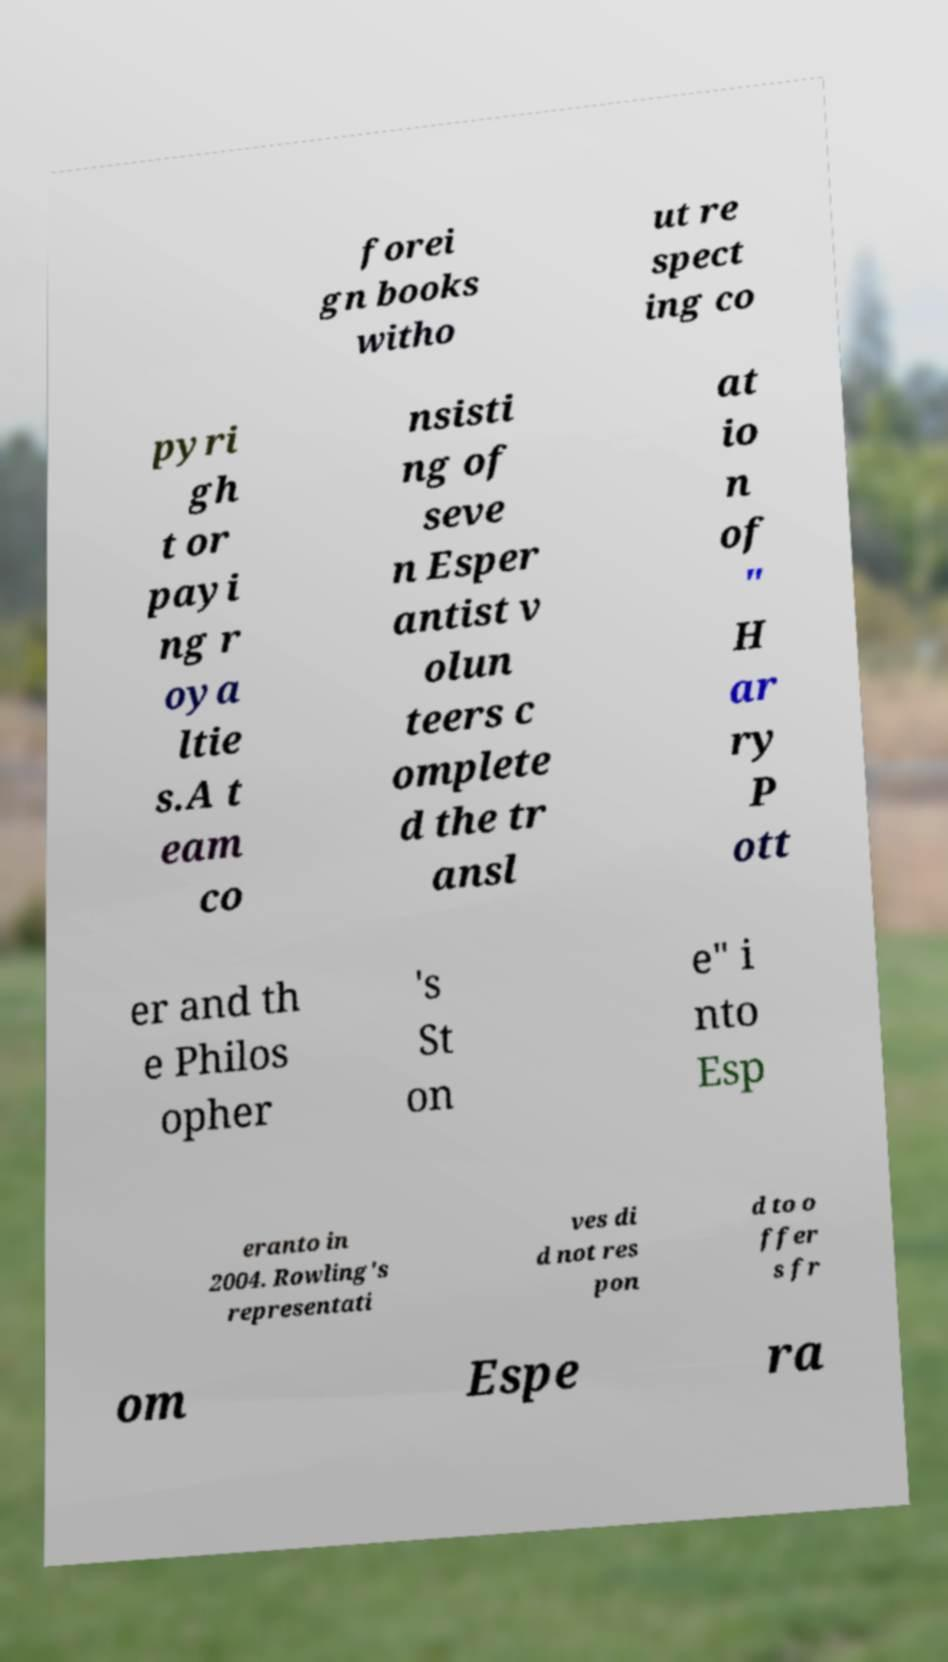Could you assist in decoding the text presented in this image and type it out clearly? forei gn books witho ut re spect ing co pyri gh t or payi ng r oya ltie s.A t eam co nsisti ng of seve n Esper antist v olun teers c omplete d the tr ansl at io n of " H ar ry P ott er and th e Philos opher 's St on e" i nto Esp eranto in 2004. Rowling's representati ves di d not res pon d to o ffer s fr om Espe ra 